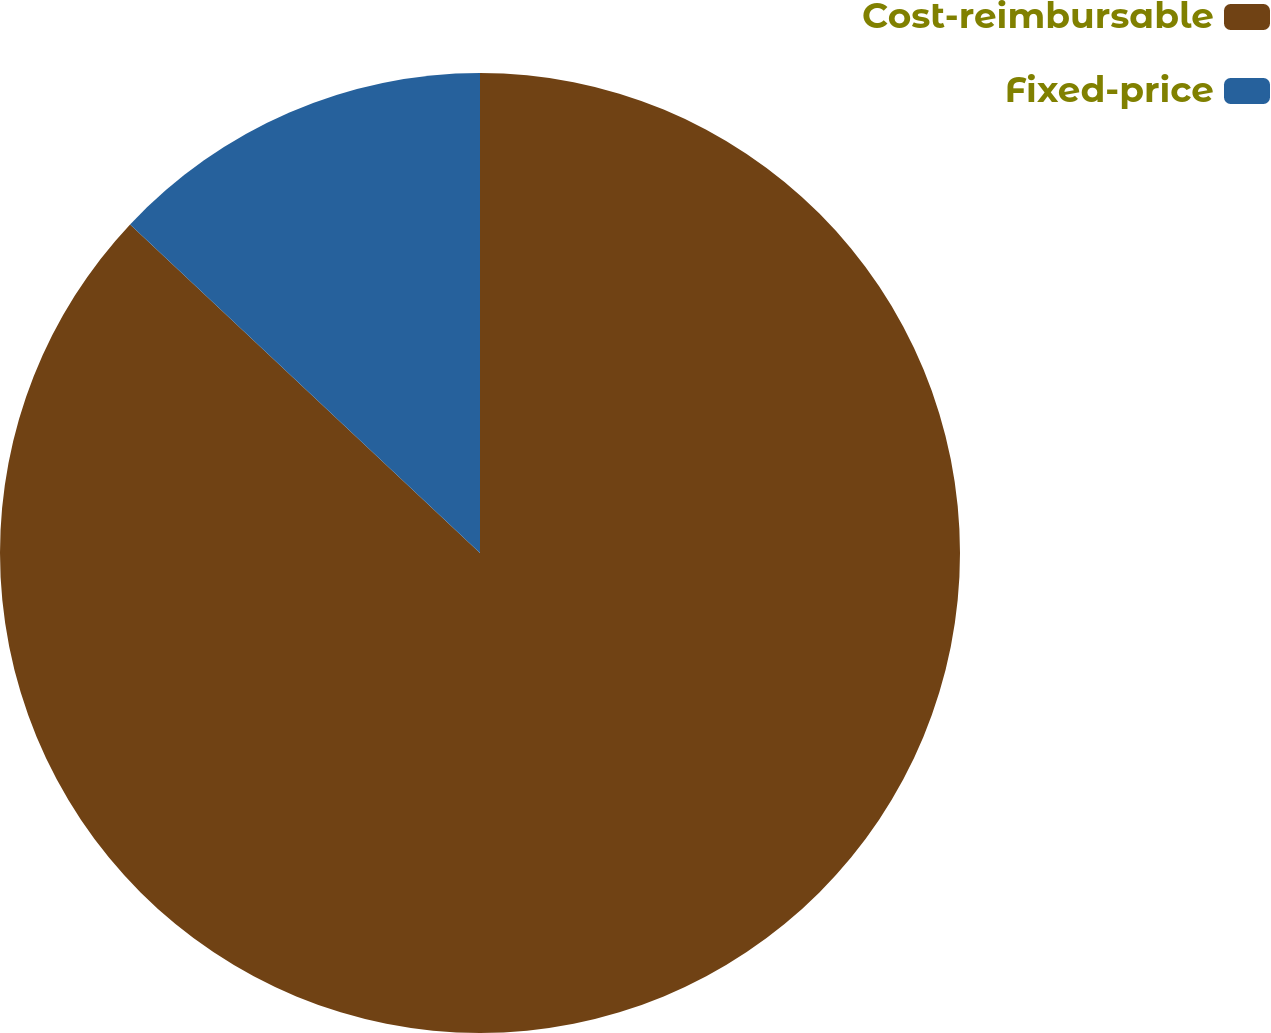<chart> <loc_0><loc_0><loc_500><loc_500><pie_chart><fcel>Cost-reimbursable<fcel>Fixed-price<nl><fcel>87.0%<fcel>13.0%<nl></chart> 